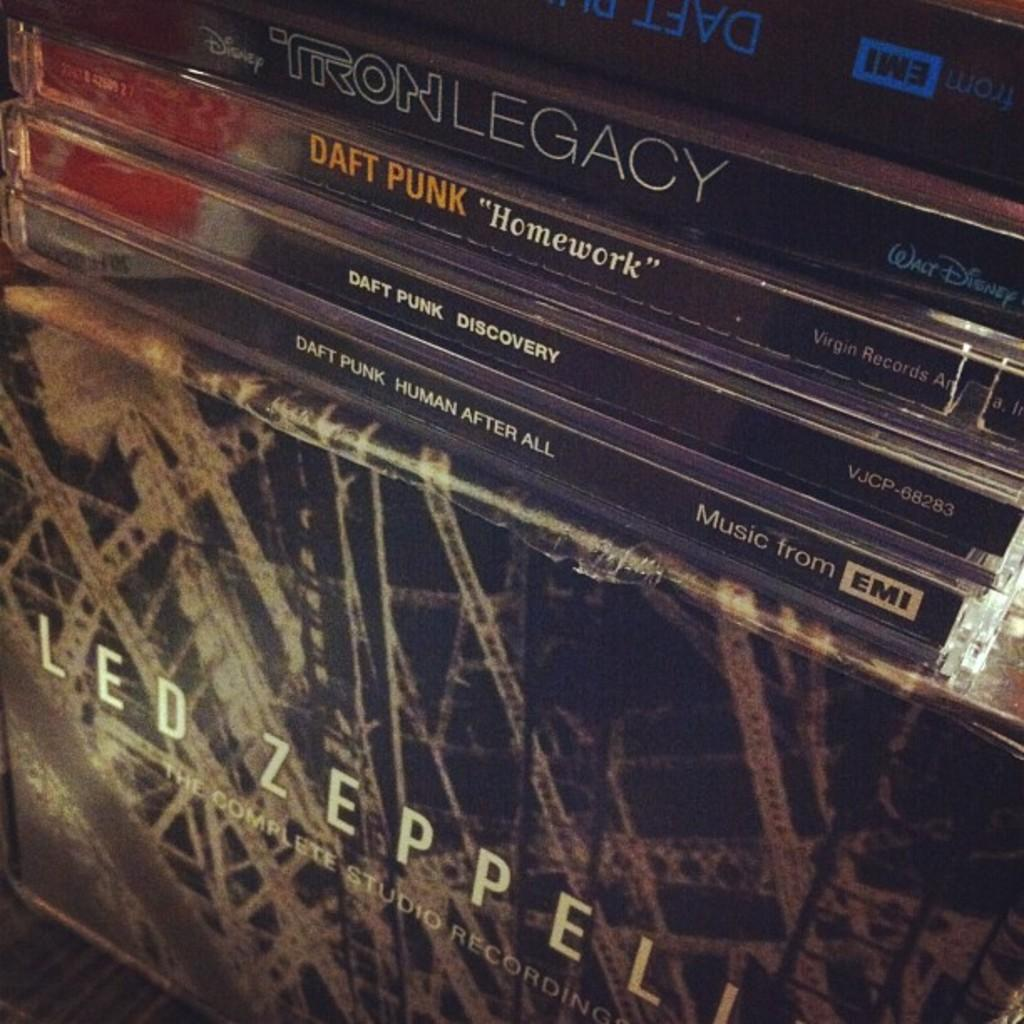<image>
Share a concise interpretation of the image provided. Music from Fadt Punk and the soundtrack from Disney's Tron Legacy are shown. 